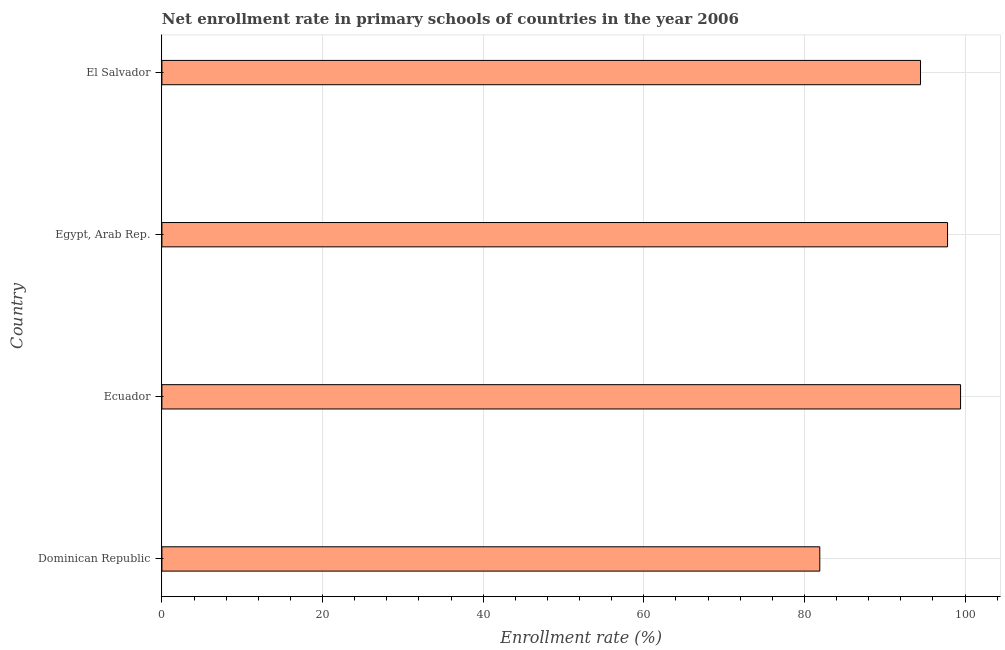Does the graph contain any zero values?
Give a very brief answer. No. What is the title of the graph?
Give a very brief answer. Net enrollment rate in primary schools of countries in the year 2006. What is the label or title of the X-axis?
Give a very brief answer. Enrollment rate (%). What is the label or title of the Y-axis?
Offer a terse response. Country. What is the net enrollment rate in primary schools in Dominican Republic?
Provide a succinct answer. 81.92. Across all countries, what is the maximum net enrollment rate in primary schools?
Keep it short and to the point. 99.45. Across all countries, what is the minimum net enrollment rate in primary schools?
Ensure brevity in your answer.  81.92. In which country was the net enrollment rate in primary schools maximum?
Provide a succinct answer. Ecuador. In which country was the net enrollment rate in primary schools minimum?
Offer a terse response. Dominican Republic. What is the sum of the net enrollment rate in primary schools?
Ensure brevity in your answer.  373.65. What is the difference between the net enrollment rate in primary schools in Dominican Republic and Ecuador?
Your answer should be very brief. -17.53. What is the average net enrollment rate in primary schools per country?
Ensure brevity in your answer.  93.41. What is the median net enrollment rate in primary schools?
Give a very brief answer. 96.14. What is the difference between the highest and the second highest net enrollment rate in primary schools?
Ensure brevity in your answer.  1.62. What is the difference between the highest and the lowest net enrollment rate in primary schools?
Provide a short and direct response. 17.53. Are all the bars in the graph horizontal?
Your response must be concise. Yes. How many countries are there in the graph?
Provide a succinct answer. 4. What is the difference between two consecutive major ticks on the X-axis?
Offer a very short reply. 20. What is the Enrollment rate (%) in Dominican Republic?
Ensure brevity in your answer.  81.92. What is the Enrollment rate (%) of Ecuador?
Your answer should be compact. 99.45. What is the Enrollment rate (%) in Egypt, Arab Rep.?
Offer a terse response. 97.83. What is the Enrollment rate (%) of El Salvador?
Give a very brief answer. 94.46. What is the difference between the Enrollment rate (%) in Dominican Republic and Ecuador?
Give a very brief answer. -17.53. What is the difference between the Enrollment rate (%) in Dominican Republic and Egypt, Arab Rep.?
Offer a very short reply. -15.91. What is the difference between the Enrollment rate (%) in Dominican Republic and El Salvador?
Offer a very short reply. -12.54. What is the difference between the Enrollment rate (%) in Ecuador and Egypt, Arab Rep.?
Make the answer very short. 1.62. What is the difference between the Enrollment rate (%) in Ecuador and El Salvador?
Offer a terse response. 4.99. What is the difference between the Enrollment rate (%) in Egypt, Arab Rep. and El Salvador?
Provide a short and direct response. 3.36. What is the ratio of the Enrollment rate (%) in Dominican Republic to that in Ecuador?
Provide a short and direct response. 0.82. What is the ratio of the Enrollment rate (%) in Dominican Republic to that in Egypt, Arab Rep.?
Your answer should be very brief. 0.84. What is the ratio of the Enrollment rate (%) in Dominican Republic to that in El Salvador?
Offer a very short reply. 0.87. What is the ratio of the Enrollment rate (%) in Ecuador to that in El Salvador?
Provide a succinct answer. 1.05. What is the ratio of the Enrollment rate (%) in Egypt, Arab Rep. to that in El Salvador?
Your answer should be compact. 1.04. 